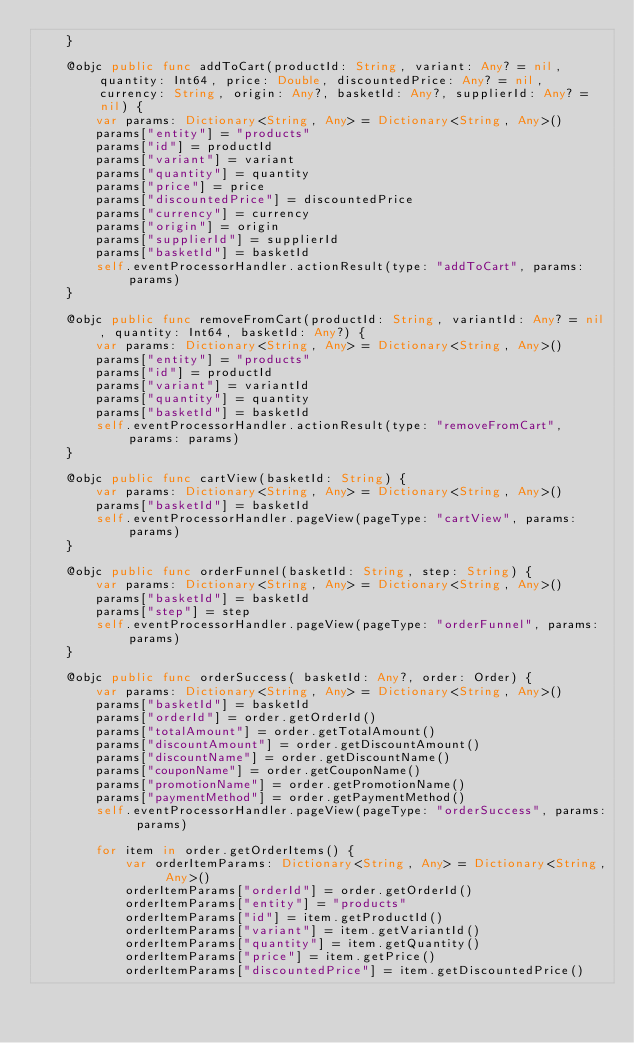Convert code to text. <code><loc_0><loc_0><loc_500><loc_500><_Swift_>    }

    @objc public func addToCart(productId: String, variant: Any? = nil, quantity: Int64, price: Double, discountedPrice: Any? = nil, currency: String, origin: Any?, basketId: Any?, supplierId: Any? = nil) {
        var params: Dictionary<String, Any> = Dictionary<String, Any>()
        params["entity"] = "products"
        params["id"] = productId
        params["variant"] = variant
        params["quantity"] = quantity
        params["price"] = price
        params["discountedPrice"] = discountedPrice
        params["currency"] = currency
        params["origin"] = origin
        params["supplierId"] = supplierId
        params["basketId"] = basketId
        self.eventProcessorHandler.actionResult(type: "addToCart", params: params)
    }

    @objc public func removeFromCart(productId: String, variantId: Any? = nil, quantity: Int64, basketId: Any?) {
        var params: Dictionary<String, Any> = Dictionary<String, Any>()
        params["entity"] = "products"
        params["id"] = productId
        params["variant"] = variantId
        params["quantity"] = quantity
        params["basketId"] = basketId
        self.eventProcessorHandler.actionResult(type: "removeFromCart", params: params)
    }

    @objc public func cartView(basketId: String) {
        var params: Dictionary<String, Any> = Dictionary<String, Any>()
        params["basketId"] = basketId
        self.eventProcessorHandler.pageView(pageType: "cartView", params: params)
    }

    @objc public func orderFunnel(basketId: String, step: String) {
        var params: Dictionary<String, Any> = Dictionary<String, Any>()
        params["basketId"] = basketId
        params["step"] = step
        self.eventProcessorHandler.pageView(pageType: "orderFunnel", params: params)
    }

    @objc public func orderSuccess( basketId: Any?, order: Order) {
        var params: Dictionary<String, Any> = Dictionary<String, Any>()
        params["basketId"] = basketId
        params["orderId"] = order.getOrderId()
        params["totalAmount"] = order.getTotalAmount()
        params["discountAmount"] = order.getDiscountAmount()
        params["discountName"] = order.getDiscountName()
        params["couponName"] = order.getCouponName()
        params["promotionName"] = order.getPromotionName()
        params["paymentMethod"] = order.getPaymentMethod()
        self.eventProcessorHandler.pageView(pageType: "orderSuccess", params: params)

        for item in order.getOrderItems() {
            var orderItemParams: Dictionary<String, Any> = Dictionary<String, Any>()
            orderItemParams["orderId"] = order.getOrderId()
            orderItemParams["entity"] = "products"
            orderItemParams["id"] = item.getProductId()
            orderItemParams["variant"] = item.getVariantId()
            orderItemParams["quantity"] = item.getQuantity()
            orderItemParams["price"] = item.getPrice()
            orderItemParams["discountedPrice"] = item.getDiscountedPrice()</code> 